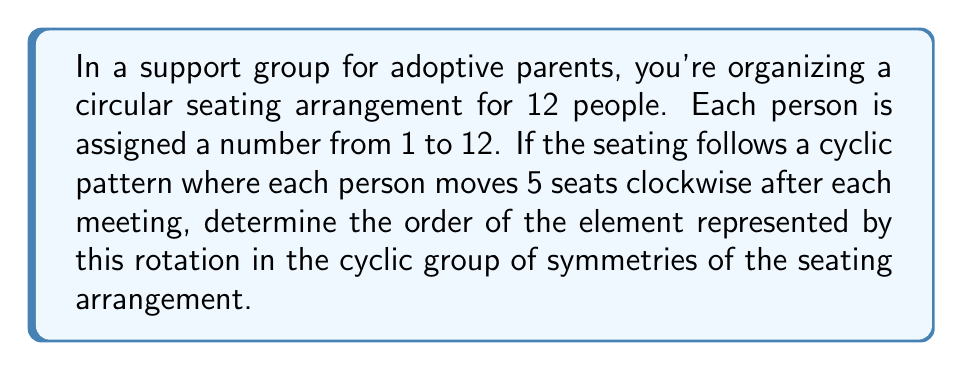What is the answer to this math problem? Let's approach this step-by-step:

1) First, we need to understand what the order of an element means in a cyclic group. The order of an element is the smallest positive integer $n$ such that $a^n = e$, where $e$ is the identity element.

2) In this case, our group is the cyclic group of rotations of a 12-person circle, which is isomorphic to $\mathbb{Z}_{12}$ (the integers modulo 12).

3) The rotation described in the question moves each person 5 seats clockwise. This can be represented as the element 5 in $\mathbb{Z}_{12}$.

4) To find the order of this element, we need to find the smallest positive integer $n$ such that $5n \equiv 0 \pmod{12}$.

5) Let's calculate the multiples of 5 modulo 12:
   $5 \cdot 1 \equiv 5 \pmod{12}$
   $5 \cdot 2 \equiv 10 \pmod{12}$
   $5 \cdot 3 \equiv 3 \pmod{12}$
   $5 \cdot 4 \equiv 8 \pmod{12}$
   $5 \cdot 5 \equiv 1 \pmod{12}$
   $5 \cdot 6 \equiv 6 \pmod{12}$
   $5 \cdot 7 \equiv 11 \pmod{12}$
   $5 \cdot 8 \equiv 4 \pmod{12}$
   $5 \cdot 9 \equiv 9 \pmod{12}$
   $5 \cdot 10 \equiv 2 \pmod{12}$
   $5 \cdot 11 \equiv 7 \pmod{12}$
   $5 \cdot 12 \equiv 0 \pmod{12}$

6) We see that the smallest positive integer $n$ such that $5n \equiv 0 \pmod{12}$ is 12.

Therefore, the order of the element represented by this rotation is 12.
Answer: The order of the element is 12. 